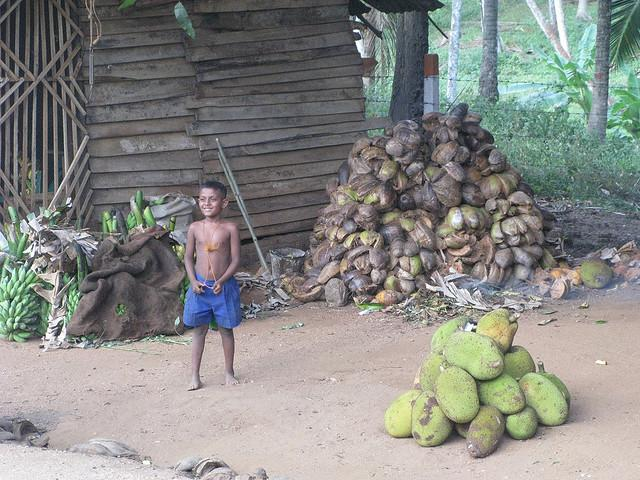What type of fruit are the green items on the boys right?

Choices:
A) bananas
B) potatoes
C) papayas
D) turnips bananas 